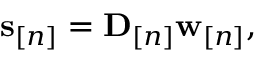Convert formula to latex. <formula><loc_0><loc_0><loc_500><loc_500>\begin{array} { r } { { s } _ { [ n ] } = { D } _ { [ n ] } \mathbf w _ { [ n ] } , \quad } \end{array}</formula> 